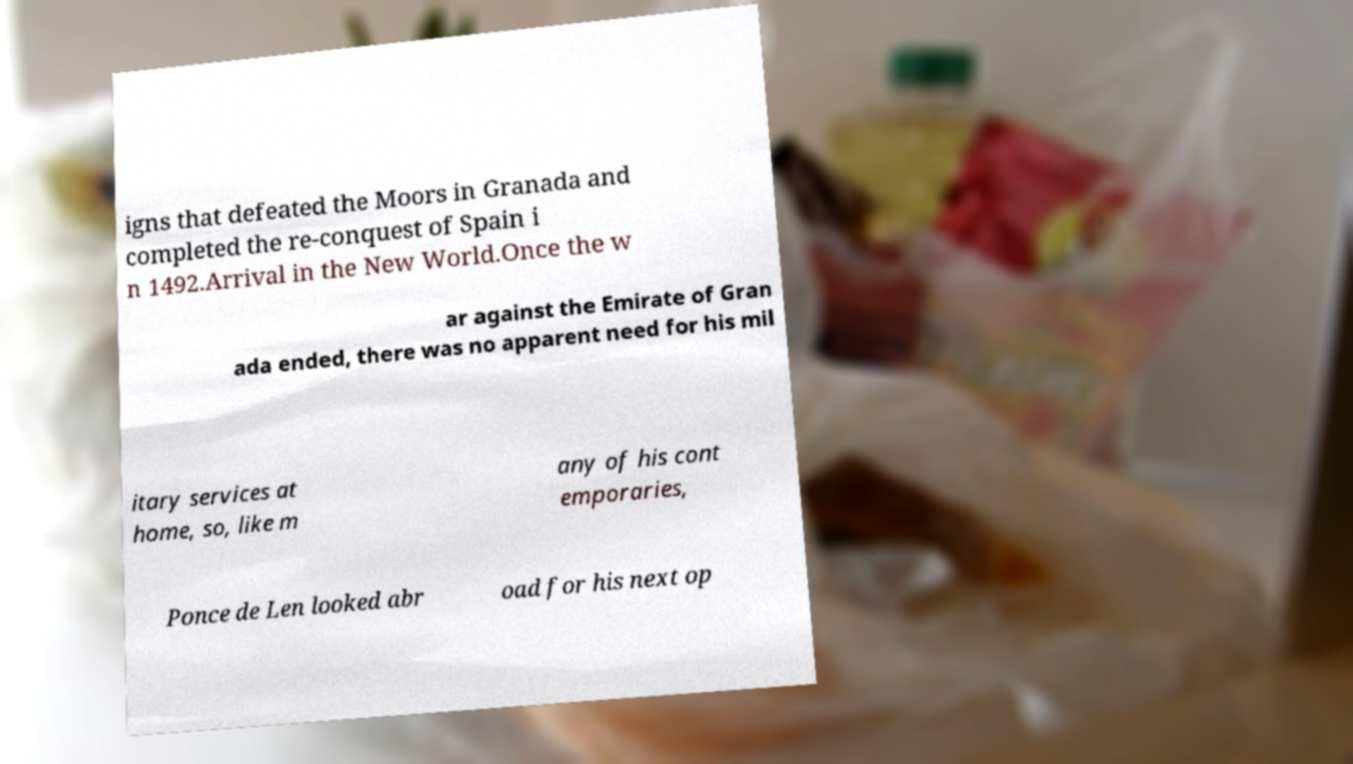Could you assist in decoding the text presented in this image and type it out clearly? igns that defeated the Moors in Granada and completed the re-conquest of Spain i n 1492.Arrival in the New World.Once the w ar against the Emirate of Gran ada ended, there was no apparent need for his mil itary services at home, so, like m any of his cont emporaries, Ponce de Len looked abr oad for his next op 